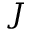Convert formula to latex. <formula><loc_0><loc_0><loc_500><loc_500>J</formula> 